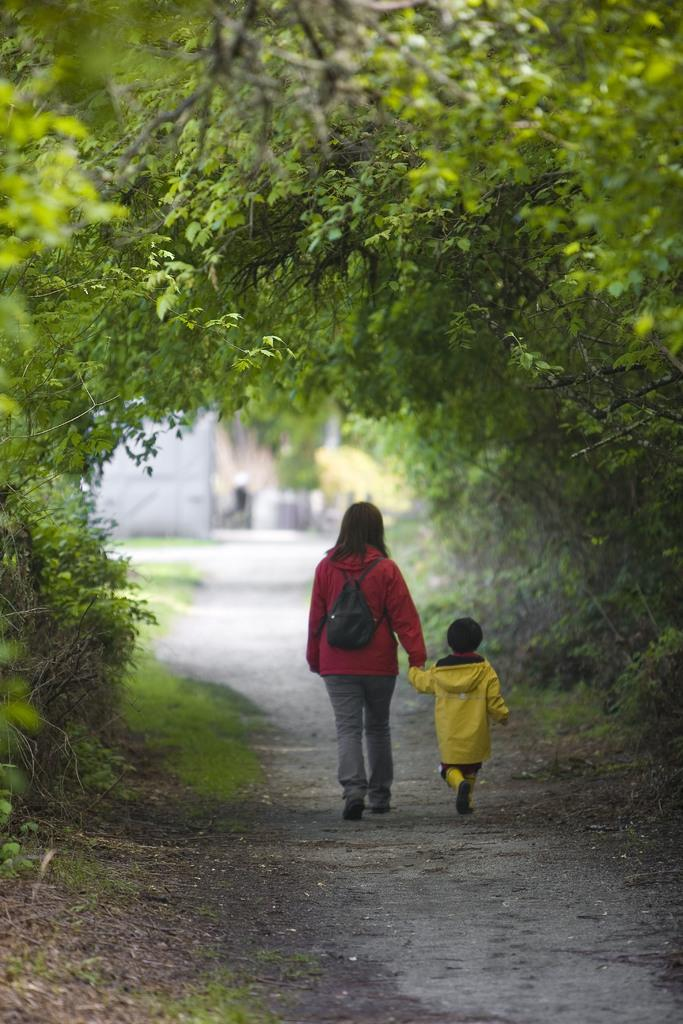How many people are in the image? There are two persons in the image. What are the persons doing in the image? The persons are standing on the road. What can be seen in the background of the image? There are trees visible in the background of the image. What type of magic trick is the person on the left performing in the image? There is no indication of a magic trick or any magical elements in the image. What kind of watch is the person on the right wearing in the image? There is no watch visible on either person in the image. 